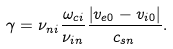<formula> <loc_0><loc_0><loc_500><loc_500>\gamma = \nu _ { n i } \frac { \omega _ { c i } } { \nu _ { i n } } \frac { \left | v _ { e 0 } - v _ { i 0 } \right | } { c _ { s n } } .</formula> 